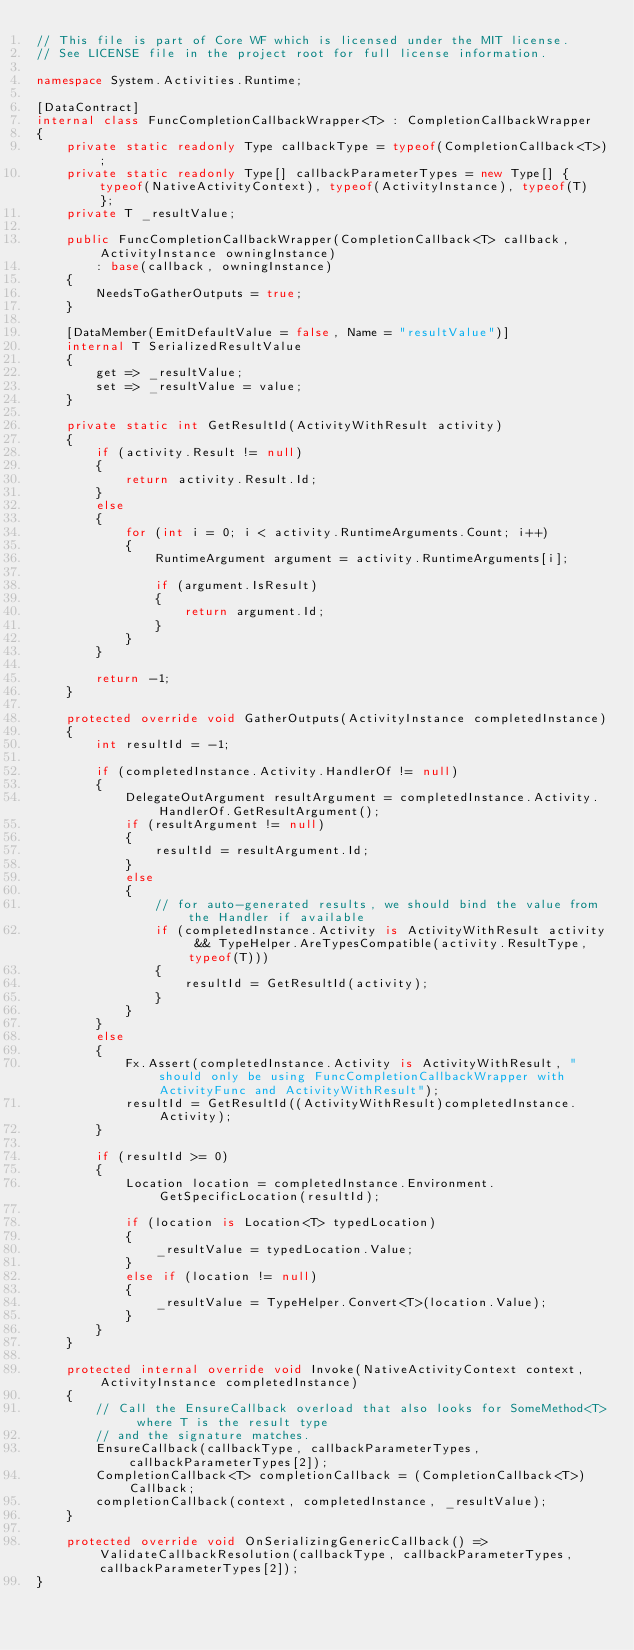Convert code to text. <code><loc_0><loc_0><loc_500><loc_500><_C#_>// This file is part of Core WF which is licensed under the MIT license.
// See LICENSE file in the project root for full license information.

namespace System.Activities.Runtime;

[DataContract]
internal class FuncCompletionCallbackWrapper<T> : CompletionCallbackWrapper
{
    private static readonly Type callbackType = typeof(CompletionCallback<T>);
    private static readonly Type[] callbackParameterTypes = new Type[] { typeof(NativeActivityContext), typeof(ActivityInstance), typeof(T) };
    private T _resultValue;

    public FuncCompletionCallbackWrapper(CompletionCallback<T> callback, ActivityInstance owningInstance)
        : base(callback, owningInstance)
    {
        NeedsToGatherOutputs = true;
    }

    [DataMember(EmitDefaultValue = false, Name = "resultValue")]
    internal T SerializedResultValue
    {
        get => _resultValue;
        set => _resultValue = value;
    }

    private static int GetResultId(ActivityWithResult activity)
    {
        if (activity.Result != null)
        {
            return activity.Result.Id;
        }
        else
        {
            for (int i = 0; i < activity.RuntimeArguments.Count; i++)
            {
                RuntimeArgument argument = activity.RuntimeArguments[i];

                if (argument.IsResult)
                {
                    return argument.Id;
                }
            }
        }

        return -1;
    }

    protected override void GatherOutputs(ActivityInstance completedInstance)
    {
        int resultId = -1;

        if (completedInstance.Activity.HandlerOf != null)
        {
            DelegateOutArgument resultArgument = completedInstance.Activity.HandlerOf.GetResultArgument();
            if (resultArgument != null)
            {
                resultId = resultArgument.Id;
            }
            else
            {
                // for auto-generated results, we should bind the value from the Handler if available
                if (completedInstance.Activity is ActivityWithResult activity && TypeHelper.AreTypesCompatible(activity.ResultType, typeof(T)))
                {
                    resultId = GetResultId(activity);
                }
            }
        }
        else
        {
            Fx.Assert(completedInstance.Activity is ActivityWithResult, "should only be using FuncCompletionCallbackWrapper with ActivityFunc and ActivityWithResult");
            resultId = GetResultId((ActivityWithResult)completedInstance.Activity);
        }

        if (resultId >= 0)
        {
            Location location = completedInstance.Environment.GetSpecificLocation(resultId);

            if (location is Location<T> typedLocation)
            {
                _resultValue = typedLocation.Value;
            }
            else if (location != null)
            {
                _resultValue = TypeHelper.Convert<T>(location.Value);
            }
        }
    }

    protected internal override void Invoke(NativeActivityContext context, ActivityInstance completedInstance)
    {
        // Call the EnsureCallback overload that also looks for SomeMethod<T> where T is the result type
        // and the signature matches.
        EnsureCallback(callbackType, callbackParameterTypes, callbackParameterTypes[2]);
        CompletionCallback<T> completionCallback = (CompletionCallback<T>)Callback;
        completionCallback(context, completedInstance, _resultValue);
    }

    protected override void OnSerializingGenericCallback() => ValidateCallbackResolution(callbackType, callbackParameterTypes, callbackParameterTypes[2]);
}
</code> 